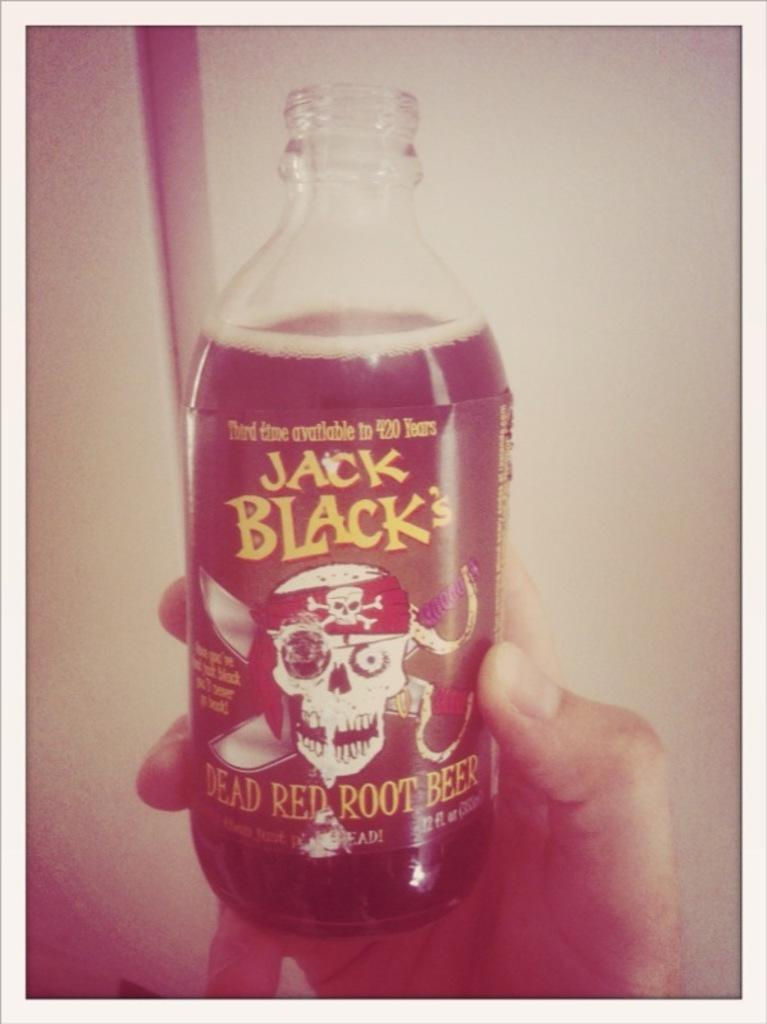<image>
Share a concise interpretation of the image provided. a close up of Jack Black's Dead Red Root Beer 